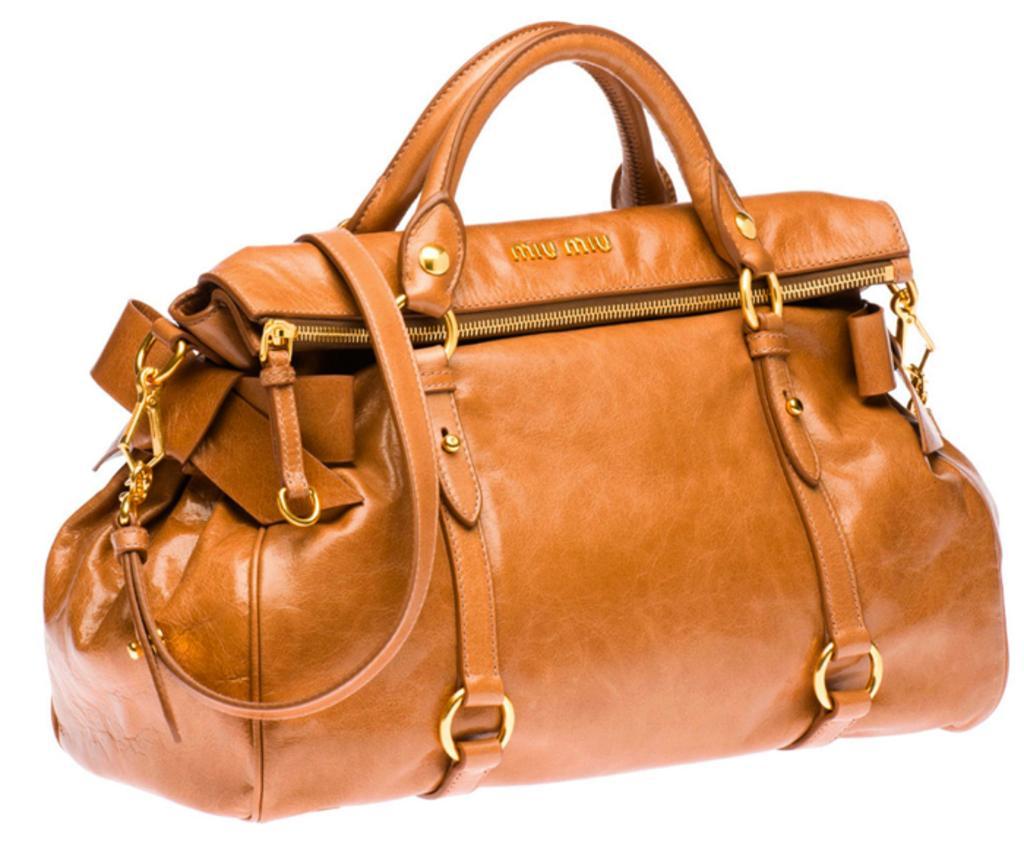Describe this image in one or two sentences. This picture describe about the photograph of the brown leather duffle bag for travelling,. On the sides it has golden hooks and zipper which help in carrying the load. 